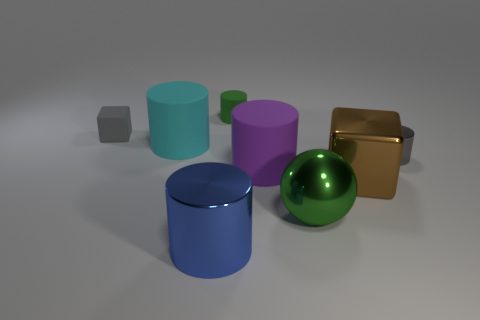Subtract all cyan cylinders. How many cylinders are left? 4 Subtract all green cylinders. How many cylinders are left? 4 Add 2 big brown metal cubes. How many objects exist? 10 Subtract all spheres. How many objects are left? 7 Subtract 1 balls. How many balls are left? 0 Subtract all small yellow rubber spheres. Subtract all tiny rubber cubes. How many objects are left? 7 Add 8 big metal blocks. How many big metal blocks are left? 9 Add 5 metal balls. How many metal balls exist? 6 Subtract 1 purple cylinders. How many objects are left? 7 Subtract all purple balls. Subtract all purple cubes. How many balls are left? 1 